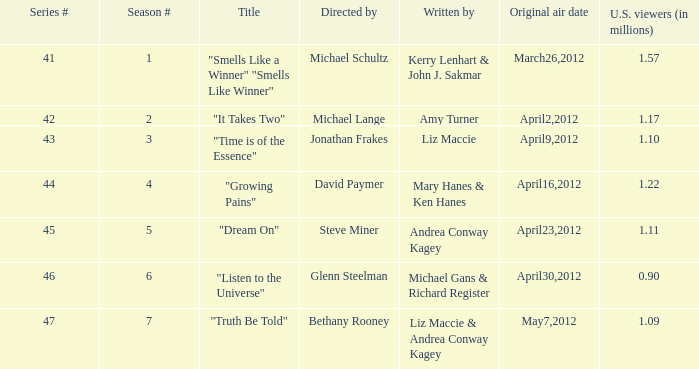10 million u.s. viewers? "Time is of the Essence". 